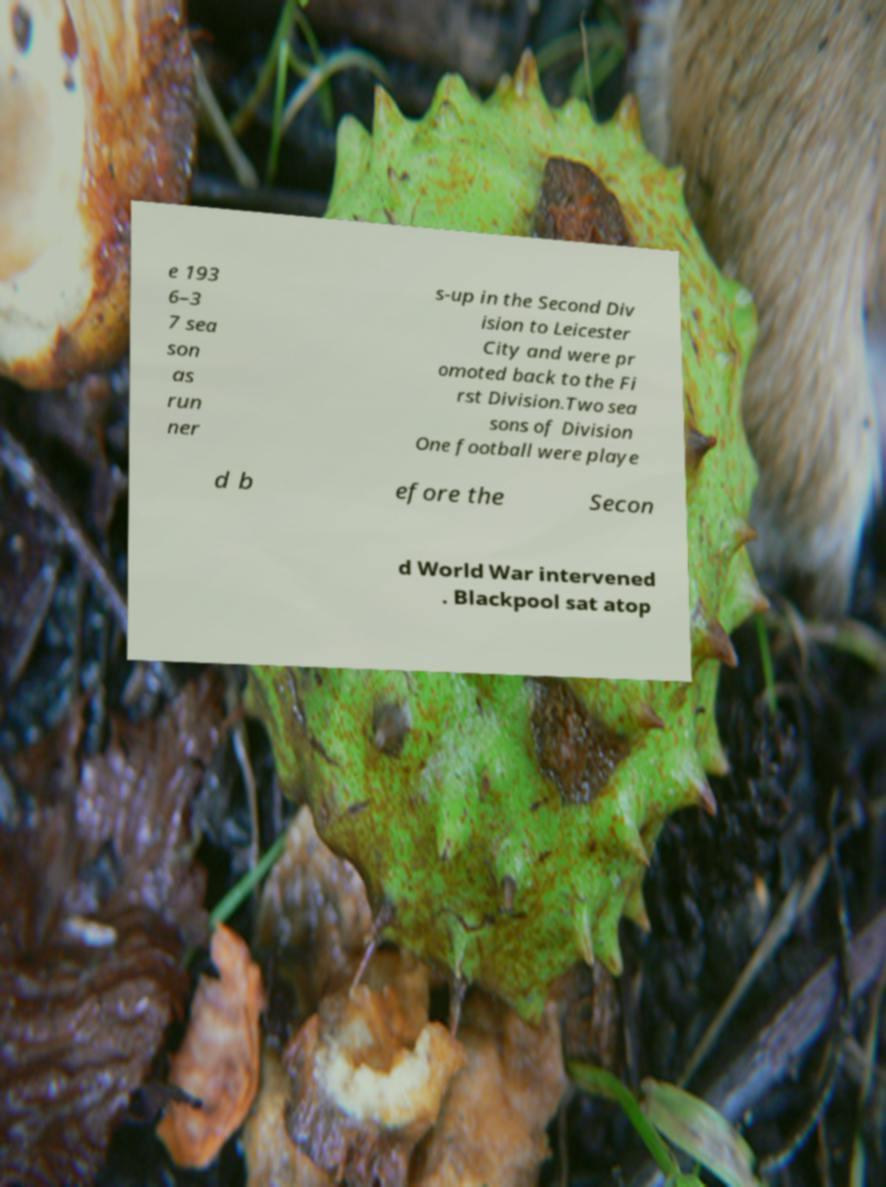Could you assist in decoding the text presented in this image and type it out clearly? e 193 6–3 7 sea son as run ner s-up in the Second Div ision to Leicester City and were pr omoted back to the Fi rst Division.Two sea sons of Division One football were playe d b efore the Secon d World War intervened . Blackpool sat atop 